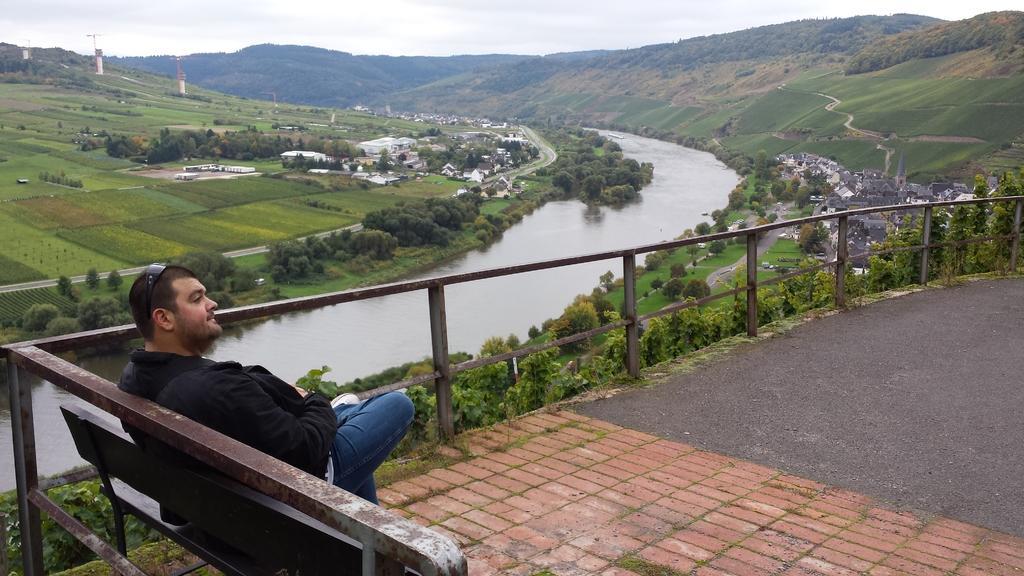Describe this image in one or two sentences. In the image there is a man sitting on a bench and behind the man there is a river, trees, a lot of greenery, mountains and houses. 